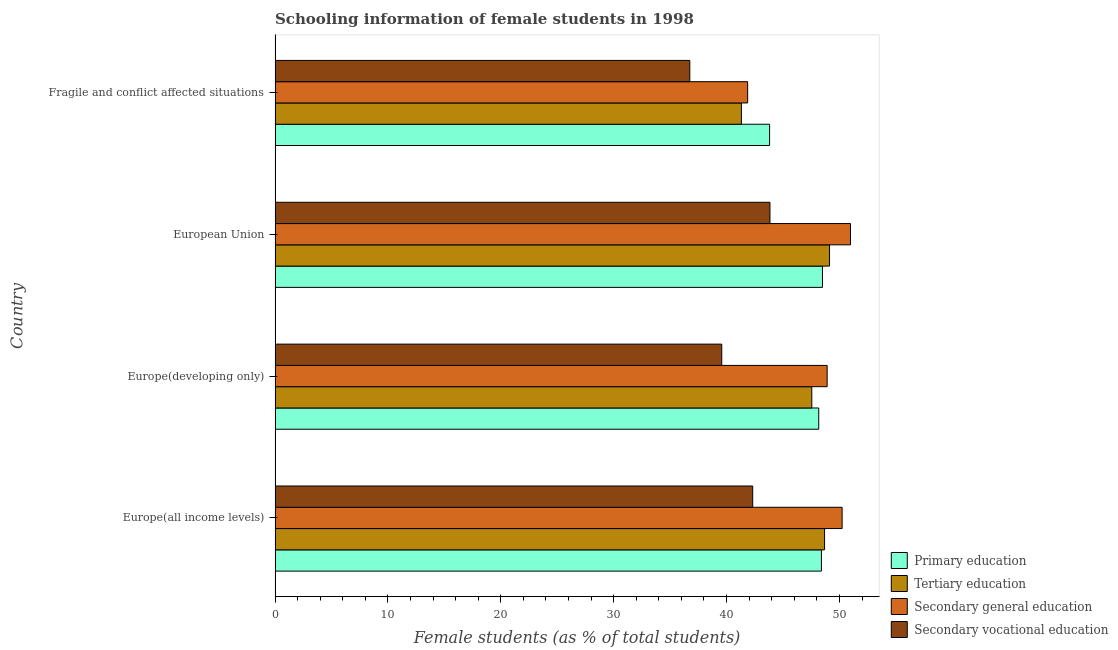How many different coloured bars are there?
Your response must be concise. 4. How many groups of bars are there?
Provide a short and direct response. 4. Are the number of bars on each tick of the Y-axis equal?
Your answer should be compact. Yes. How many bars are there on the 1st tick from the bottom?
Your answer should be very brief. 4. What is the percentage of female students in secondary education in Europe(developing only)?
Your response must be concise. 48.91. Across all countries, what is the maximum percentage of female students in tertiary education?
Offer a terse response. 49.12. Across all countries, what is the minimum percentage of female students in primary education?
Your response must be concise. 43.81. In which country was the percentage of female students in secondary vocational education minimum?
Offer a terse response. Fragile and conflict affected situations. What is the total percentage of female students in secondary vocational education in the graph?
Your answer should be compact. 162.48. What is the difference between the percentage of female students in tertiary education in Europe(all income levels) and that in European Union?
Your response must be concise. -0.44. What is the difference between the percentage of female students in secondary vocational education in Europe(all income levels) and the percentage of female students in secondary education in Fragile and conflict affected situations?
Keep it short and to the point. 0.45. What is the average percentage of female students in secondary vocational education per country?
Provide a short and direct response. 40.62. What is the difference between the percentage of female students in secondary education and percentage of female students in tertiary education in Europe(developing only)?
Offer a terse response. 1.36. What is the ratio of the percentage of female students in secondary vocational education in Europe(all income levels) to that in Europe(developing only)?
Ensure brevity in your answer.  1.07. Is the percentage of female students in secondary vocational education in Europe(developing only) less than that in European Union?
Your response must be concise. Yes. What is the difference between the highest and the second highest percentage of female students in tertiary education?
Provide a succinct answer. 0.44. What is the difference between the highest and the lowest percentage of female students in secondary vocational education?
Provide a short and direct response. 7.1. In how many countries, is the percentage of female students in primary education greater than the average percentage of female students in primary education taken over all countries?
Provide a short and direct response. 3. Is the sum of the percentage of female students in primary education in Europe(developing only) and European Union greater than the maximum percentage of female students in secondary vocational education across all countries?
Your answer should be compact. Yes. Is it the case that in every country, the sum of the percentage of female students in tertiary education and percentage of female students in secondary education is greater than the sum of percentage of female students in secondary vocational education and percentage of female students in primary education?
Your response must be concise. Yes. What does the 3rd bar from the bottom in European Union represents?
Give a very brief answer. Secondary general education. Is it the case that in every country, the sum of the percentage of female students in primary education and percentage of female students in tertiary education is greater than the percentage of female students in secondary education?
Offer a terse response. Yes. How many bars are there?
Provide a succinct answer. 16. Where does the legend appear in the graph?
Your response must be concise. Bottom right. How many legend labels are there?
Offer a terse response. 4. How are the legend labels stacked?
Your response must be concise. Vertical. What is the title of the graph?
Offer a terse response. Schooling information of female students in 1998. Does "Japan" appear as one of the legend labels in the graph?
Your answer should be very brief. No. What is the label or title of the X-axis?
Ensure brevity in your answer.  Female students (as % of total students). What is the label or title of the Y-axis?
Ensure brevity in your answer.  Country. What is the Female students (as % of total students) in Primary education in Europe(all income levels)?
Your answer should be compact. 48.4. What is the Female students (as % of total students) in Tertiary education in Europe(all income levels)?
Your answer should be compact. 48.68. What is the Female students (as % of total students) of Secondary general education in Europe(all income levels)?
Offer a very short reply. 50.24. What is the Female students (as % of total students) of Secondary vocational education in Europe(all income levels)?
Offer a terse response. 42.32. What is the Female students (as % of total students) in Primary education in Europe(developing only)?
Your answer should be compact. 48.17. What is the Female students (as % of total students) in Tertiary education in Europe(developing only)?
Provide a succinct answer. 47.55. What is the Female students (as % of total students) of Secondary general education in Europe(developing only)?
Keep it short and to the point. 48.91. What is the Female students (as % of total students) of Secondary vocational education in Europe(developing only)?
Provide a succinct answer. 39.57. What is the Female students (as % of total students) of Primary education in European Union?
Keep it short and to the point. 48.5. What is the Female students (as % of total students) in Tertiary education in European Union?
Offer a very short reply. 49.12. What is the Female students (as % of total students) of Secondary general education in European Union?
Your answer should be compact. 50.98. What is the Female students (as % of total students) of Secondary vocational education in European Union?
Provide a short and direct response. 43.84. What is the Female students (as % of total students) in Primary education in Fragile and conflict affected situations?
Provide a succinct answer. 43.81. What is the Female students (as % of total students) in Tertiary education in Fragile and conflict affected situations?
Provide a short and direct response. 41.32. What is the Female students (as % of total students) of Secondary general education in Fragile and conflict affected situations?
Offer a terse response. 41.87. What is the Female students (as % of total students) of Secondary vocational education in Fragile and conflict affected situations?
Your response must be concise. 36.74. Across all countries, what is the maximum Female students (as % of total students) in Primary education?
Offer a very short reply. 48.5. Across all countries, what is the maximum Female students (as % of total students) in Tertiary education?
Offer a terse response. 49.12. Across all countries, what is the maximum Female students (as % of total students) in Secondary general education?
Ensure brevity in your answer.  50.98. Across all countries, what is the maximum Female students (as % of total students) of Secondary vocational education?
Provide a short and direct response. 43.84. Across all countries, what is the minimum Female students (as % of total students) of Primary education?
Offer a very short reply. 43.81. Across all countries, what is the minimum Female students (as % of total students) of Tertiary education?
Your response must be concise. 41.32. Across all countries, what is the minimum Female students (as % of total students) of Secondary general education?
Your answer should be compact. 41.87. Across all countries, what is the minimum Female students (as % of total students) of Secondary vocational education?
Provide a short and direct response. 36.74. What is the total Female students (as % of total students) of Primary education in the graph?
Your response must be concise. 188.88. What is the total Female students (as % of total students) of Tertiary education in the graph?
Your response must be concise. 186.67. What is the total Female students (as % of total students) in Secondary general education in the graph?
Provide a short and direct response. 192. What is the total Female students (as % of total students) of Secondary vocational education in the graph?
Make the answer very short. 162.48. What is the difference between the Female students (as % of total students) of Primary education in Europe(all income levels) and that in Europe(developing only)?
Give a very brief answer. 0.24. What is the difference between the Female students (as % of total students) of Tertiary education in Europe(all income levels) and that in Europe(developing only)?
Your answer should be very brief. 1.13. What is the difference between the Female students (as % of total students) in Secondary general education in Europe(all income levels) and that in Europe(developing only)?
Give a very brief answer. 1.33. What is the difference between the Female students (as % of total students) of Secondary vocational education in Europe(all income levels) and that in Europe(developing only)?
Offer a terse response. 2.74. What is the difference between the Female students (as % of total students) in Primary education in Europe(all income levels) and that in European Union?
Provide a short and direct response. -0.09. What is the difference between the Female students (as % of total students) in Tertiary education in Europe(all income levels) and that in European Union?
Your answer should be compact. -0.44. What is the difference between the Female students (as % of total students) of Secondary general education in Europe(all income levels) and that in European Union?
Your response must be concise. -0.74. What is the difference between the Female students (as % of total students) of Secondary vocational education in Europe(all income levels) and that in European Union?
Offer a very short reply. -1.53. What is the difference between the Female students (as % of total students) of Primary education in Europe(all income levels) and that in Fragile and conflict affected situations?
Offer a terse response. 4.59. What is the difference between the Female students (as % of total students) of Tertiary education in Europe(all income levels) and that in Fragile and conflict affected situations?
Your response must be concise. 7.37. What is the difference between the Female students (as % of total students) of Secondary general education in Europe(all income levels) and that in Fragile and conflict affected situations?
Offer a terse response. 8.37. What is the difference between the Female students (as % of total students) of Secondary vocational education in Europe(all income levels) and that in Fragile and conflict affected situations?
Provide a succinct answer. 5.57. What is the difference between the Female students (as % of total students) of Primary education in Europe(developing only) and that in European Union?
Ensure brevity in your answer.  -0.33. What is the difference between the Female students (as % of total students) in Tertiary education in Europe(developing only) and that in European Union?
Your answer should be compact. -1.57. What is the difference between the Female students (as % of total students) of Secondary general education in Europe(developing only) and that in European Union?
Keep it short and to the point. -2.07. What is the difference between the Female students (as % of total students) of Secondary vocational education in Europe(developing only) and that in European Union?
Your answer should be compact. -4.27. What is the difference between the Female students (as % of total students) in Primary education in Europe(developing only) and that in Fragile and conflict affected situations?
Provide a short and direct response. 4.35. What is the difference between the Female students (as % of total students) in Tertiary education in Europe(developing only) and that in Fragile and conflict affected situations?
Your answer should be very brief. 6.23. What is the difference between the Female students (as % of total students) of Secondary general education in Europe(developing only) and that in Fragile and conflict affected situations?
Provide a short and direct response. 7.04. What is the difference between the Female students (as % of total students) of Secondary vocational education in Europe(developing only) and that in Fragile and conflict affected situations?
Offer a very short reply. 2.83. What is the difference between the Female students (as % of total students) of Primary education in European Union and that in Fragile and conflict affected situations?
Your answer should be very brief. 4.69. What is the difference between the Female students (as % of total students) of Tertiary education in European Union and that in Fragile and conflict affected situations?
Your response must be concise. 7.81. What is the difference between the Female students (as % of total students) in Secondary general education in European Union and that in Fragile and conflict affected situations?
Ensure brevity in your answer.  9.11. What is the difference between the Female students (as % of total students) in Secondary vocational education in European Union and that in Fragile and conflict affected situations?
Offer a terse response. 7.1. What is the difference between the Female students (as % of total students) of Primary education in Europe(all income levels) and the Female students (as % of total students) of Tertiary education in Europe(developing only)?
Keep it short and to the point. 0.85. What is the difference between the Female students (as % of total students) in Primary education in Europe(all income levels) and the Female students (as % of total students) in Secondary general education in Europe(developing only)?
Provide a succinct answer. -0.51. What is the difference between the Female students (as % of total students) of Primary education in Europe(all income levels) and the Female students (as % of total students) of Secondary vocational education in Europe(developing only)?
Offer a terse response. 8.83. What is the difference between the Female students (as % of total students) of Tertiary education in Europe(all income levels) and the Female students (as % of total students) of Secondary general education in Europe(developing only)?
Ensure brevity in your answer.  -0.23. What is the difference between the Female students (as % of total students) of Tertiary education in Europe(all income levels) and the Female students (as % of total students) of Secondary vocational education in Europe(developing only)?
Offer a terse response. 9.11. What is the difference between the Female students (as % of total students) in Secondary general education in Europe(all income levels) and the Female students (as % of total students) in Secondary vocational education in Europe(developing only)?
Make the answer very short. 10.66. What is the difference between the Female students (as % of total students) of Primary education in Europe(all income levels) and the Female students (as % of total students) of Tertiary education in European Union?
Offer a very short reply. -0.72. What is the difference between the Female students (as % of total students) in Primary education in Europe(all income levels) and the Female students (as % of total students) in Secondary general education in European Union?
Your response must be concise. -2.58. What is the difference between the Female students (as % of total students) of Primary education in Europe(all income levels) and the Female students (as % of total students) of Secondary vocational education in European Union?
Provide a short and direct response. 4.56. What is the difference between the Female students (as % of total students) in Tertiary education in Europe(all income levels) and the Female students (as % of total students) in Secondary general education in European Union?
Ensure brevity in your answer.  -2.3. What is the difference between the Female students (as % of total students) of Tertiary education in Europe(all income levels) and the Female students (as % of total students) of Secondary vocational education in European Union?
Give a very brief answer. 4.84. What is the difference between the Female students (as % of total students) in Secondary general education in Europe(all income levels) and the Female students (as % of total students) in Secondary vocational education in European Union?
Provide a short and direct response. 6.39. What is the difference between the Female students (as % of total students) of Primary education in Europe(all income levels) and the Female students (as % of total students) of Tertiary education in Fragile and conflict affected situations?
Provide a short and direct response. 7.09. What is the difference between the Female students (as % of total students) in Primary education in Europe(all income levels) and the Female students (as % of total students) in Secondary general education in Fragile and conflict affected situations?
Provide a succinct answer. 6.54. What is the difference between the Female students (as % of total students) in Primary education in Europe(all income levels) and the Female students (as % of total students) in Secondary vocational education in Fragile and conflict affected situations?
Make the answer very short. 11.66. What is the difference between the Female students (as % of total students) of Tertiary education in Europe(all income levels) and the Female students (as % of total students) of Secondary general education in Fragile and conflict affected situations?
Provide a succinct answer. 6.81. What is the difference between the Female students (as % of total students) of Tertiary education in Europe(all income levels) and the Female students (as % of total students) of Secondary vocational education in Fragile and conflict affected situations?
Ensure brevity in your answer.  11.94. What is the difference between the Female students (as % of total students) of Secondary general education in Europe(all income levels) and the Female students (as % of total students) of Secondary vocational education in Fragile and conflict affected situations?
Your answer should be very brief. 13.5. What is the difference between the Female students (as % of total students) in Primary education in Europe(developing only) and the Female students (as % of total students) in Tertiary education in European Union?
Ensure brevity in your answer.  -0.96. What is the difference between the Female students (as % of total students) of Primary education in Europe(developing only) and the Female students (as % of total students) of Secondary general education in European Union?
Keep it short and to the point. -2.81. What is the difference between the Female students (as % of total students) in Primary education in Europe(developing only) and the Female students (as % of total students) in Secondary vocational education in European Union?
Your answer should be very brief. 4.32. What is the difference between the Female students (as % of total students) of Tertiary education in Europe(developing only) and the Female students (as % of total students) of Secondary general education in European Union?
Ensure brevity in your answer.  -3.43. What is the difference between the Female students (as % of total students) of Tertiary education in Europe(developing only) and the Female students (as % of total students) of Secondary vocational education in European Union?
Offer a very short reply. 3.71. What is the difference between the Female students (as % of total students) in Secondary general education in Europe(developing only) and the Female students (as % of total students) in Secondary vocational education in European Union?
Provide a short and direct response. 5.07. What is the difference between the Female students (as % of total students) in Primary education in Europe(developing only) and the Female students (as % of total students) in Tertiary education in Fragile and conflict affected situations?
Offer a terse response. 6.85. What is the difference between the Female students (as % of total students) of Primary education in Europe(developing only) and the Female students (as % of total students) of Secondary general education in Fragile and conflict affected situations?
Provide a short and direct response. 6.3. What is the difference between the Female students (as % of total students) of Primary education in Europe(developing only) and the Female students (as % of total students) of Secondary vocational education in Fragile and conflict affected situations?
Keep it short and to the point. 11.42. What is the difference between the Female students (as % of total students) of Tertiary education in Europe(developing only) and the Female students (as % of total students) of Secondary general education in Fragile and conflict affected situations?
Ensure brevity in your answer.  5.68. What is the difference between the Female students (as % of total students) of Tertiary education in Europe(developing only) and the Female students (as % of total students) of Secondary vocational education in Fragile and conflict affected situations?
Keep it short and to the point. 10.81. What is the difference between the Female students (as % of total students) of Secondary general education in Europe(developing only) and the Female students (as % of total students) of Secondary vocational education in Fragile and conflict affected situations?
Provide a short and direct response. 12.17. What is the difference between the Female students (as % of total students) of Primary education in European Union and the Female students (as % of total students) of Tertiary education in Fragile and conflict affected situations?
Give a very brief answer. 7.18. What is the difference between the Female students (as % of total students) of Primary education in European Union and the Female students (as % of total students) of Secondary general education in Fragile and conflict affected situations?
Provide a succinct answer. 6.63. What is the difference between the Female students (as % of total students) in Primary education in European Union and the Female students (as % of total students) in Secondary vocational education in Fragile and conflict affected situations?
Make the answer very short. 11.76. What is the difference between the Female students (as % of total students) of Tertiary education in European Union and the Female students (as % of total students) of Secondary general education in Fragile and conflict affected situations?
Your response must be concise. 7.26. What is the difference between the Female students (as % of total students) in Tertiary education in European Union and the Female students (as % of total students) in Secondary vocational education in Fragile and conflict affected situations?
Provide a short and direct response. 12.38. What is the difference between the Female students (as % of total students) of Secondary general education in European Union and the Female students (as % of total students) of Secondary vocational education in Fragile and conflict affected situations?
Give a very brief answer. 14.24. What is the average Female students (as % of total students) of Primary education per country?
Make the answer very short. 47.22. What is the average Female students (as % of total students) in Tertiary education per country?
Provide a short and direct response. 46.67. What is the average Female students (as % of total students) in Secondary general education per country?
Keep it short and to the point. 48. What is the average Female students (as % of total students) in Secondary vocational education per country?
Ensure brevity in your answer.  40.62. What is the difference between the Female students (as % of total students) in Primary education and Female students (as % of total students) in Tertiary education in Europe(all income levels)?
Your answer should be compact. -0.28. What is the difference between the Female students (as % of total students) of Primary education and Female students (as % of total students) of Secondary general education in Europe(all income levels)?
Your answer should be very brief. -1.83. What is the difference between the Female students (as % of total students) of Primary education and Female students (as % of total students) of Secondary vocational education in Europe(all income levels)?
Keep it short and to the point. 6.09. What is the difference between the Female students (as % of total students) of Tertiary education and Female students (as % of total students) of Secondary general education in Europe(all income levels)?
Make the answer very short. -1.56. What is the difference between the Female students (as % of total students) in Tertiary education and Female students (as % of total students) in Secondary vocational education in Europe(all income levels)?
Keep it short and to the point. 6.37. What is the difference between the Female students (as % of total students) in Secondary general education and Female students (as % of total students) in Secondary vocational education in Europe(all income levels)?
Offer a very short reply. 7.92. What is the difference between the Female students (as % of total students) in Primary education and Female students (as % of total students) in Tertiary education in Europe(developing only)?
Offer a terse response. 0.62. What is the difference between the Female students (as % of total students) in Primary education and Female students (as % of total students) in Secondary general education in Europe(developing only)?
Keep it short and to the point. -0.75. What is the difference between the Female students (as % of total students) in Primary education and Female students (as % of total students) in Secondary vocational education in Europe(developing only)?
Keep it short and to the point. 8.59. What is the difference between the Female students (as % of total students) in Tertiary education and Female students (as % of total students) in Secondary general education in Europe(developing only)?
Offer a terse response. -1.36. What is the difference between the Female students (as % of total students) in Tertiary education and Female students (as % of total students) in Secondary vocational education in Europe(developing only)?
Keep it short and to the point. 7.98. What is the difference between the Female students (as % of total students) of Secondary general education and Female students (as % of total students) of Secondary vocational education in Europe(developing only)?
Make the answer very short. 9.34. What is the difference between the Female students (as % of total students) of Primary education and Female students (as % of total students) of Tertiary education in European Union?
Your response must be concise. -0.63. What is the difference between the Female students (as % of total students) of Primary education and Female students (as % of total students) of Secondary general education in European Union?
Offer a terse response. -2.48. What is the difference between the Female students (as % of total students) in Primary education and Female students (as % of total students) in Secondary vocational education in European Union?
Provide a short and direct response. 4.65. What is the difference between the Female students (as % of total students) of Tertiary education and Female students (as % of total students) of Secondary general education in European Union?
Offer a very short reply. -1.86. What is the difference between the Female students (as % of total students) in Tertiary education and Female students (as % of total students) in Secondary vocational education in European Union?
Your answer should be very brief. 5.28. What is the difference between the Female students (as % of total students) of Secondary general education and Female students (as % of total students) of Secondary vocational education in European Union?
Provide a succinct answer. 7.14. What is the difference between the Female students (as % of total students) in Primary education and Female students (as % of total students) in Tertiary education in Fragile and conflict affected situations?
Your answer should be compact. 2.5. What is the difference between the Female students (as % of total students) of Primary education and Female students (as % of total students) of Secondary general education in Fragile and conflict affected situations?
Give a very brief answer. 1.94. What is the difference between the Female students (as % of total students) of Primary education and Female students (as % of total students) of Secondary vocational education in Fragile and conflict affected situations?
Offer a terse response. 7.07. What is the difference between the Female students (as % of total students) of Tertiary education and Female students (as % of total students) of Secondary general education in Fragile and conflict affected situations?
Your response must be concise. -0.55. What is the difference between the Female students (as % of total students) in Tertiary education and Female students (as % of total students) in Secondary vocational education in Fragile and conflict affected situations?
Provide a succinct answer. 4.57. What is the difference between the Female students (as % of total students) in Secondary general education and Female students (as % of total students) in Secondary vocational education in Fragile and conflict affected situations?
Your answer should be compact. 5.13. What is the ratio of the Female students (as % of total students) in Tertiary education in Europe(all income levels) to that in Europe(developing only)?
Make the answer very short. 1.02. What is the ratio of the Female students (as % of total students) in Secondary general education in Europe(all income levels) to that in Europe(developing only)?
Your answer should be compact. 1.03. What is the ratio of the Female students (as % of total students) in Secondary vocational education in Europe(all income levels) to that in Europe(developing only)?
Your response must be concise. 1.07. What is the ratio of the Female students (as % of total students) of Secondary general education in Europe(all income levels) to that in European Union?
Your answer should be very brief. 0.99. What is the ratio of the Female students (as % of total students) in Secondary vocational education in Europe(all income levels) to that in European Union?
Provide a succinct answer. 0.97. What is the ratio of the Female students (as % of total students) of Primary education in Europe(all income levels) to that in Fragile and conflict affected situations?
Your answer should be very brief. 1.1. What is the ratio of the Female students (as % of total students) in Tertiary education in Europe(all income levels) to that in Fragile and conflict affected situations?
Your answer should be compact. 1.18. What is the ratio of the Female students (as % of total students) of Secondary general education in Europe(all income levels) to that in Fragile and conflict affected situations?
Your answer should be very brief. 1.2. What is the ratio of the Female students (as % of total students) of Secondary vocational education in Europe(all income levels) to that in Fragile and conflict affected situations?
Your answer should be very brief. 1.15. What is the ratio of the Female students (as % of total students) in Tertiary education in Europe(developing only) to that in European Union?
Offer a very short reply. 0.97. What is the ratio of the Female students (as % of total students) in Secondary general education in Europe(developing only) to that in European Union?
Give a very brief answer. 0.96. What is the ratio of the Female students (as % of total students) in Secondary vocational education in Europe(developing only) to that in European Union?
Your answer should be compact. 0.9. What is the ratio of the Female students (as % of total students) of Primary education in Europe(developing only) to that in Fragile and conflict affected situations?
Make the answer very short. 1.1. What is the ratio of the Female students (as % of total students) in Tertiary education in Europe(developing only) to that in Fragile and conflict affected situations?
Provide a succinct answer. 1.15. What is the ratio of the Female students (as % of total students) of Secondary general education in Europe(developing only) to that in Fragile and conflict affected situations?
Your answer should be very brief. 1.17. What is the ratio of the Female students (as % of total students) of Secondary vocational education in Europe(developing only) to that in Fragile and conflict affected situations?
Offer a terse response. 1.08. What is the ratio of the Female students (as % of total students) of Primary education in European Union to that in Fragile and conflict affected situations?
Your answer should be compact. 1.11. What is the ratio of the Female students (as % of total students) in Tertiary education in European Union to that in Fragile and conflict affected situations?
Your response must be concise. 1.19. What is the ratio of the Female students (as % of total students) of Secondary general education in European Union to that in Fragile and conflict affected situations?
Your answer should be very brief. 1.22. What is the ratio of the Female students (as % of total students) of Secondary vocational education in European Union to that in Fragile and conflict affected situations?
Keep it short and to the point. 1.19. What is the difference between the highest and the second highest Female students (as % of total students) in Primary education?
Offer a very short reply. 0.09. What is the difference between the highest and the second highest Female students (as % of total students) in Tertiary education?
Your response must be concise. 0.44. What is the difference between the highest and the second highest Female students (as % of total students) of Secondary general education?
Your answer should be compact. 0.74. What is the difference between the highest and the second highest Female students (as % of total students) of Secondary vocational education?
Provide a succinct answer. 1.53. What is the difference between the highest and the lowest Female students (as % of total students) of Primary education?
Give a very brief answer. 4.69. What is the difference between the highest and the lowest Female students (as % of total students) in Tertiary education?
Provide a succinct answer. 7.81. What is the difference between the highest and the lowest Female students (as % of total students) of Secondary general education?
Give a very brief answer. 9.11. What is the difference between the highest and the lowest Female students (as % of total students) of Secondary vocational education?
Your answer should be very brief. 7.1. 